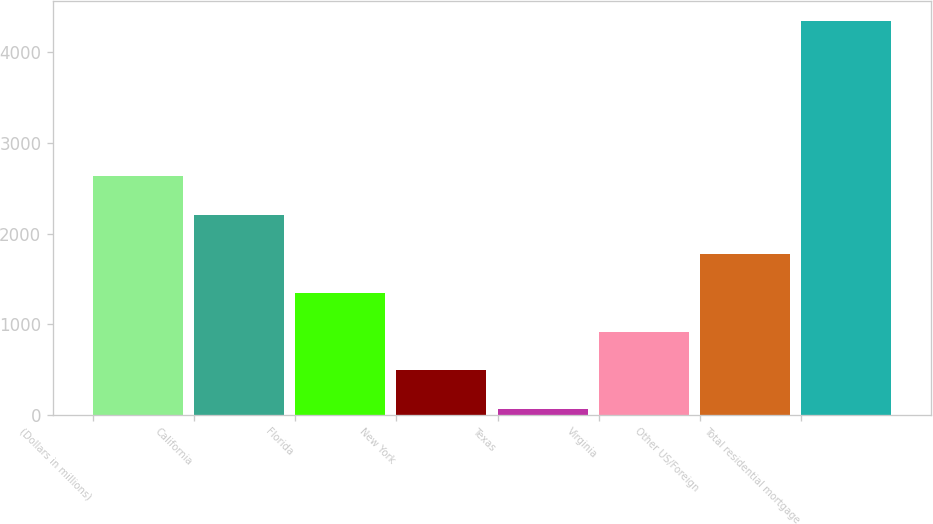Convert chart to OTSL. <chart><loc_0><loc_0><loc_500><loc_500><bar_chart><fcel>(Dollars in millions)<fcel>California<fcel>Florida<fcel>New York<fcel>Texas<fcel>Virginia<fcel>Other US/Foreign<fcel>Total residential mortgage<nl><fcel>2633.6<fcel>2204.5<fcel>1346.3<fcel>488.1<fcel>59<fcel>917.2<fcel>1775.4<fcel>4350<nl></chart> 